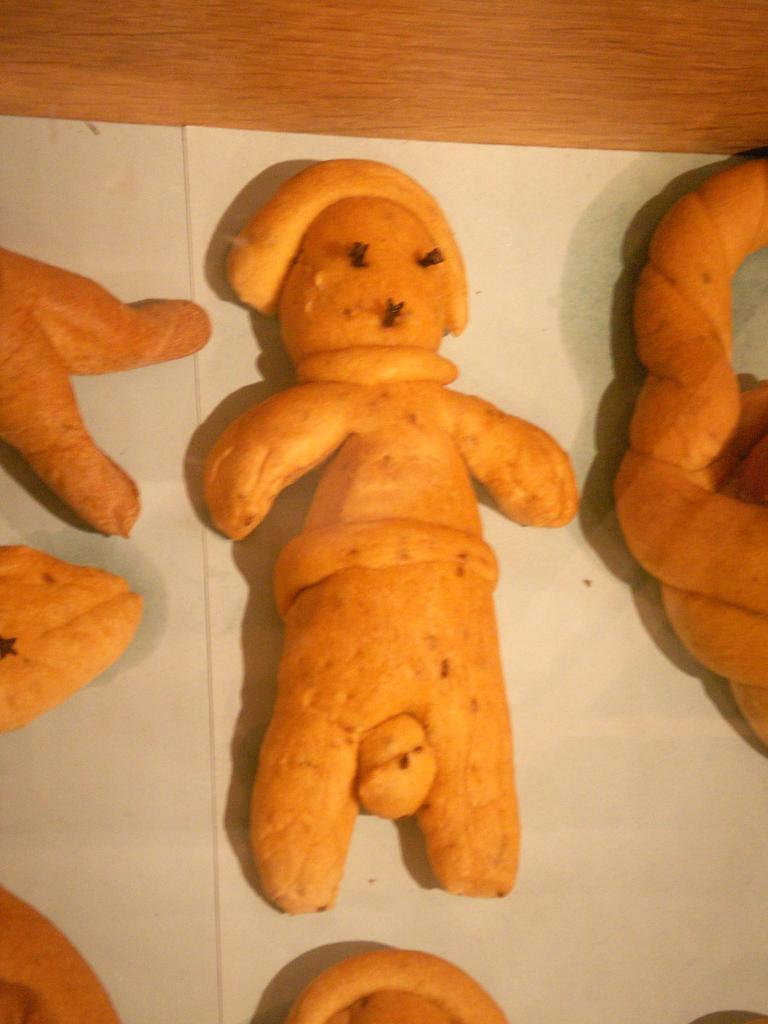What are the toys made of in the image? The toys are made of carrots in the image. What is the background of the toys in the image? The toys are placed on white paper in the image. What type of surface is the white paper placed on? The white paper is placed on a wooden table in the image. What type of riddle can be seen written on the vest of the pig in the image? There is no pig or vest with a riddle present in the image. 